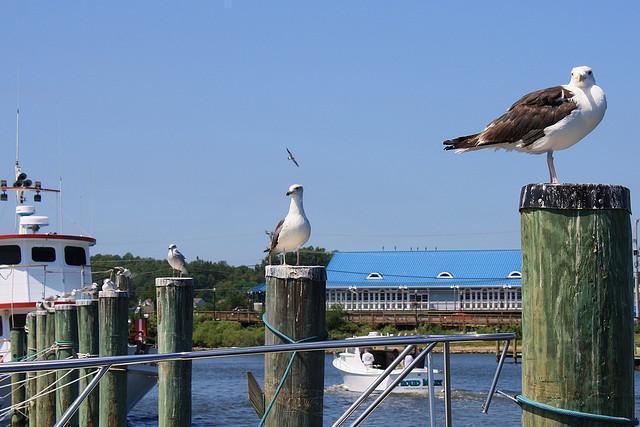What vessels are tied to the piers here?
Select the accurate answer and provide justification: `Answer: choice
Rationale: srationale.`
Options: Cars, rafts, boats, horse buggies. Answer: boats.
Rationale: Boats would be tied so they don't float away. 